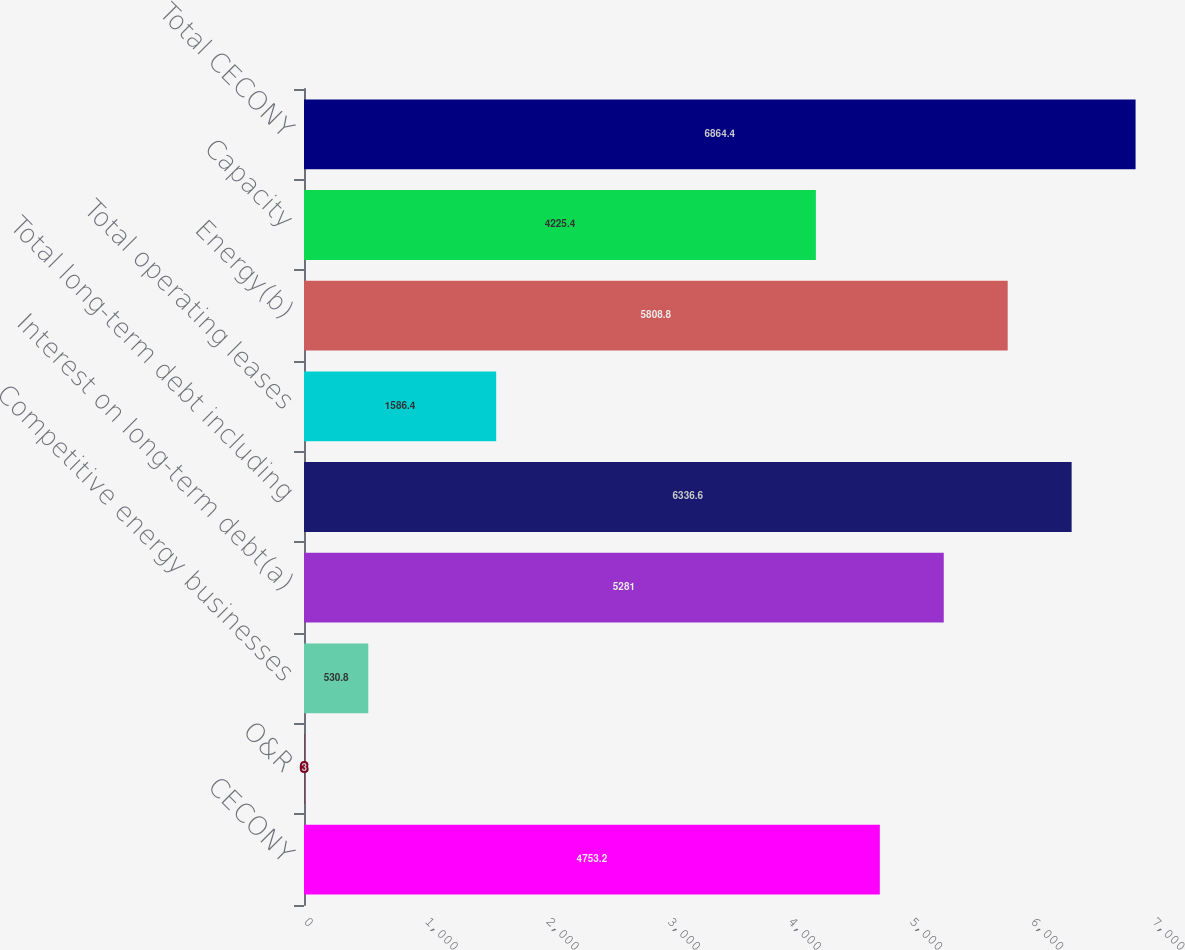Convert chart to OTSL. <chart><loc_0><loc_0><loc_500><loc_500><bar_chart><fcel>CECONY<fcel>O&R<fcel>Competitive energy businesses<fcel>Interest on long-term debt(a)<fcel>Total long-term debt including<fcel>Total operating leases<fcel>Energy(b)<fcel>Capacity<fcel>Total CECONY<nl><fcel>4753.2<fcel>3<fcel>530.8<fcel>5281<fcel>6336.6<fcel>1586.4<fcel>5808.8<fcel>4225.4<fcel>6864.4<nl></chart> 